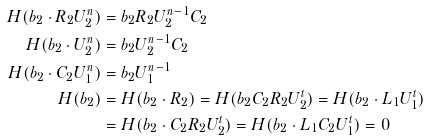<formula> <loc_0><loc_0><loc_500><loc_500>H ( b _ { 2 } \cdot R _ { 2 } U _ { 2 } ^ { n } ) & = b _ { 2 } R _ { 2 } U _ { 2 } ^ { n - 1 } C _ { 2 } \\ H ( b _ { 2 } \cdot U _ { 2 } ^ { n } ) & = b _ { 2 } U _ { 2 } ^ { n - 1 } C _ { 2 } \\ H ( b _ { 2 } \cdot C _ { 2 } U _ { 1 } ^ { n } ) & = b _ { 2 } U _ { 1 } ^ { n - 1 } \\ H ( b _ { 2 } ) & = H ( b _ { 2 } \cdot R _ { 2 } ) = H ( b _ { 2 } C _ { 2 } R _ { 2 } U _ { 2 } ^ { t } ) = H ( b _ { 2 } \cdot L _ { 1 } U _ { 1 } ^ { t } ) \\ & = H ( b _ { 2 } \cdot C _ { 2 } R _ { 2 } U _ { 2 } ^ { t } ) = H ( b _ { 2 } \cdot L _ { 1 } C _ { 2 } U _ { 1 } ^ { t } ) = 0</formula> 